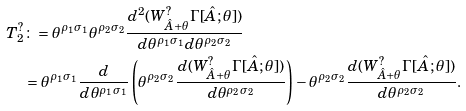Convert formula to latex. <formula><loc_0><loc_0><loc_500><loc_500>T _ { 2 } ^ { ? } & \colon = \theta ^ { \rho _ { 1 } \sigma _ { 1 } } \theta ^ { \rho _ { 2 } \sigma _ { 2 } } \frac { d ^ { 2 } ( W ^ { ? } _ { \hat { A } + \theta } \Gamma [ \hat { A } ; \theta ] ) } { d \theta ^ { \rho _ { 1 } \sigma _ { 1 } } d \theta ^ { \rho _ { 2 } \sigma _ { 2 } } } \\ & = \theta ^ { \rho _ { 1 } \sigma _ { 1 } } \frac { d } { d \theta ^ { \rho _ { 1 } \sigma _ { 1 } } } \left ( \theta ^ { \rho _ { 2 } \sigma _ { 2 } } \frac { d ( W ^ { ? } _ { \hat { A } + \theta } \Gamma [ \hat { A } ; \theta ] ) } { d \theta ^ { \rho _ { 2 } \sigma _ { 2 } } } \right ) - \theta ^ { \rho _ { 2 } \sigma _ { 2 } } \frac { d ( W ^ { ? } _ { \hat { A } + \theta } \Gamma [ \hat { A } ; \theta ] ) } { d \theta ^ { \rho _ { 2 } \sigma _ { 2 } } } .</formula> 